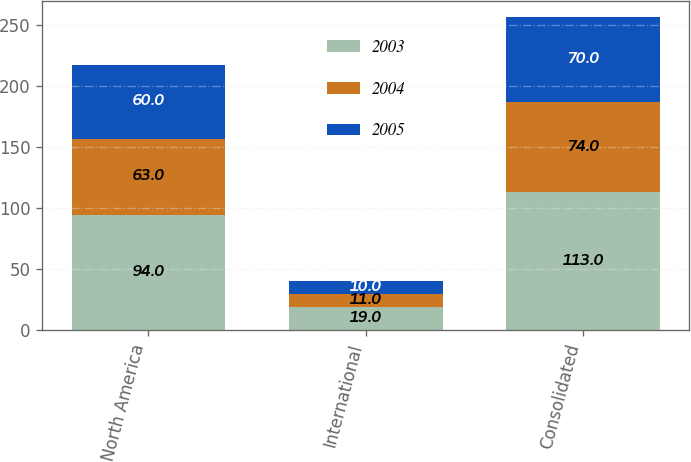<chart> <loc_0><loc_0><loc_500><loc_500><stacked_bar_chart><ecel><fcel>North America<fcel>International<fcel>Consolidated<nl><fcel>2003<fcel>94<fcel>19<fcel>113<nl><fcel>2004<fcel>63<fcel>11<fcel>74<nl><fcel>2005<fcel>60<fcel>10<fcel>70<nl></chart> 